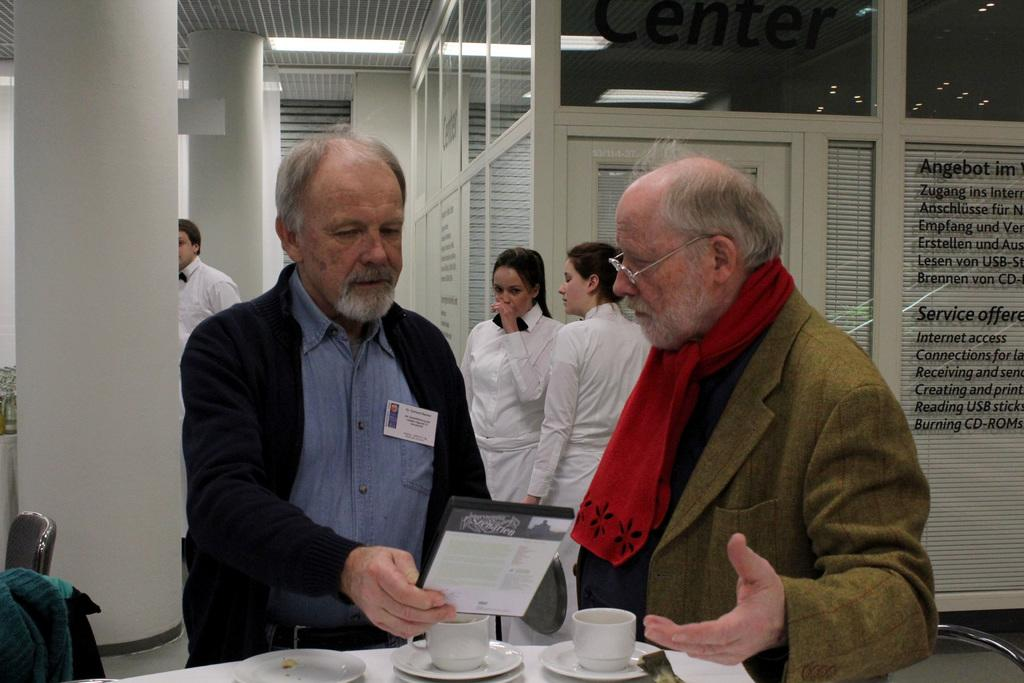What objects are located at the bottom of the image? There are cups at the bottom of the image. What can be seen in the middle of the image? There are people in the middle of the image. What is written or displayed on the glass walls in the image? There is text on the glass walls in the image. What type of lighting is present at the top of the image? There are ceiling lights at the top of the image. What type of music is being played in the image? There is no information about music being played in the image. How does the person in the image get a haircut? There is no information about a haircut in the image. 